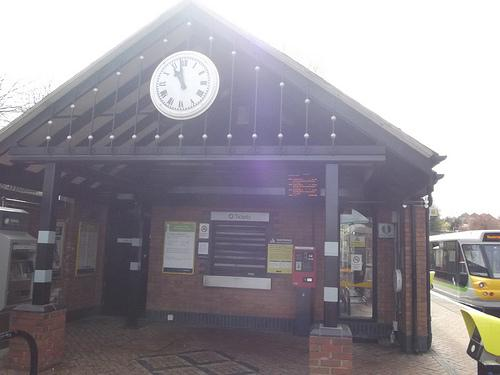What type of station is depicted in the image and the predominant architectural elements? A train station is depicted in the image, and the predominant architectural elements are brick walls, pillars, metal bars, and a clock on the building. What is the main focus of the image and its predominant color attributes? A clock on a building at a train station is the main focus, with white and black as the predominant color attributes. Briefly mention the features of the train and its surroundings in the image. The train at the station is white and yellow with a sign and a front window. The train is surrounded by architecture like brick walls, pillars, and a clock on the building. State the primary objects depicted in the image and their spatial relationships. A clock on a building at a train station is the primary object, surrounded by elements such as the train, platform, and architectural features like brick walls and pillars. Mention the noteworthy details of the clock in the image. The clock is white, has roman numerals, a black inner circle, and is located on the building at the train station. Explain the composition of the image in terms of objects and their significant characteristics. The image shows a clock on a building with roman numerals, a train station platform, a train with a sign, and several architectural elements like brick walls and pillars. In your own words, describe the setup of the train station and its ambiance. The train station has a classic ambiance, featuring a white clock with roman numerals on a brick building, a train on the platform, and various architectural details such as brick walls and pillars. Identify the architectural style of the building that is housing the clock. The building has a brick architecture and features a clock with roman numerals. Identify the types of signs present in the image and their locations. There are signs on the train, on the wall near the clock, and an updated electric sign, located in various parts of the image such as the train, wall, and the station platform. How many unique objects can be seen in the image? Mention some of their characteristics. There are 34 unique objects in the image, including a clock with roman numerals, a train with a sign, brick walls, pillars, a metal bar, and several other architectural details. Describe the expression of a person waiting at the station. There is no person visible in the image. What is the format of the numbers on the white clock? Roman numerals Describe the building's materials and the clock it features. The building is made of brick and features a white clock with roman numerals. Formulate a poetic description of the clock on the building. "A timeless sentinel in white, gracing the facade with Roman might." Provide a brief description of the scene portrayed in the image. A train station platform with a clock on the building, a train waiting, and signs displayed. Can you see the head of the train and the front window from this angle? Yes What is the theme of the building's design? Brick and wood Which of these options best describes the appearance of the clock on the building: (1) white with roman numerals, (2) black with roman numerals, (3) white with standard numbers, or (4) black with standard numbers? White with roman numerals Mention any signage present on the train. There is a sign on the train. Are there any visible signs or electronic displays in the image? Yes, there is an updated electric sign. Create a headline for a news article about the newly installed clock at the station. "Roman Numeral Clock Graces Historic Brick Train Station" What color is the clock on the building? White What other objects can be seen at the station? Red machine, glass door, sign on the wall What is the predominant color of the train at the station? White and yellow Identify the main architectural elements of the building. Brick walls, wooden columns, and metal bars What type of flooring can be seen in front of the building? Floor made of bricks Create an advertisement for the station using key features from the image. "Experience the charm of our historic brick station with state-of-the-art trains, all under the watchful gaze of our elegant white clock!" 